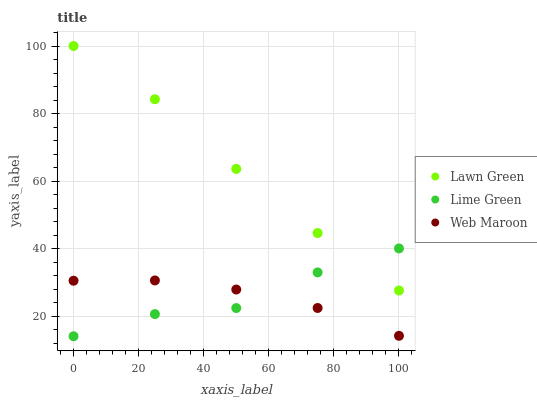Does Lime Green have the minimum area under the curve?
Answer yes or no. Yes. Does Lawn Green have the maximum area under the curve?
Answer yes or no. Yes. Does Web Maroon have the minimum area under the curve?
Answer yes or no. No. Does Web Maroon have the maximum area under the curve?
Answer yes or no. No. Is Web Maroon the smoothest?
Answer yes or no. Yes. Is Lime Green the roughest?
Answer yes or no. Yes. Is Lime Green the smoothest?
Answer yes or no. No. Is Web Maroon the roughest?
Answer yes or no. No. Does Lime Green have the lowest value?
Answer yes or no. Yes. Does Web Maroon have the lowest value?
Answer yes or no. No. Does Lawn Green have the highest value?
Answer yes or no. Yes. Does Lime Green have the highest value?
Answer yes or no. No. Is Web Maroon less than Lawn Green?
Answer yes or no. Yes. Is Lawn Green greater than Web Maroon?
Answer yes or no. Yes. Does Lime Green intersect Lawn Green?
Answer yes or no. Yes. Is Lime Green less than Lawn Green?
Answer yes or no. No. Is Lime Green greater than Lawn Green?
Answer yes or no. No. Does Web Maroon intersect Lawn Green?
Answer yes or no. No. 